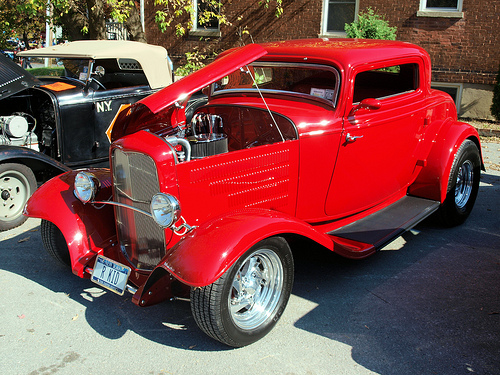<image>
Can you confirm if the light is behind the car? No. The light is not behind the car. From this viewpoint, the light appears to be positioned elsewhere in the scene. 